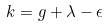Convert formula to latex. <formula><loc_0><loc_0><loc_500><loc_500>k = g + \lambda - \epsilon</formula> 